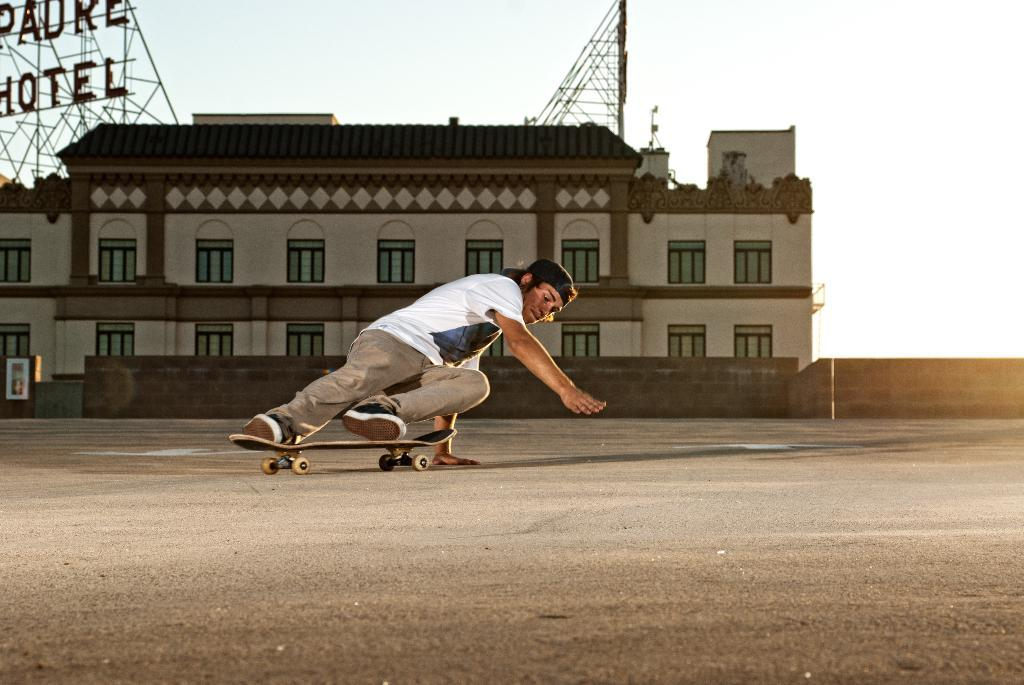Who is the main subject in the image? There is a man in the image. What is the man doing in the image? The man is riding a board in the image. What can be seen in the background of the image? There is a building in the image. What feature of the building is mentioned in the facts? The building has windows. How many houses are visible in the image? There is no mention of houses in the image; only a building is mentioned. Are there any babies present in the image? There is no mention of babies in the image. 